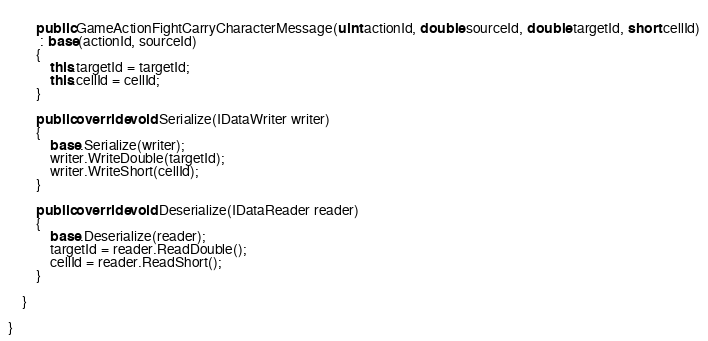Convert code to text. <code><loc_0><loc_0><loc_500><loc_500><_C#_>        
        public GameActionFightCarryCharacterMessage(uint actionId, double sourceId, double targetId, short cellId)
         : base(actionId, sourceId)
        {
            this.targetId = targetId;
            this.cellId = cellId;
        }
        
        public override void Serialize(IDataWriter writer)
        {
            base.Serialize(writer);
            writer.WriteDouble(targetId);
            writer.WriteShort(cellId);
        }
        
        public override void Deserialize(IDataReader reader)
        {
            base.Deserialize(reader);
            targetId = reader.ReadDouble();
            cellId = reader.ReadShort();
        }
        
    }
    
}</code> 